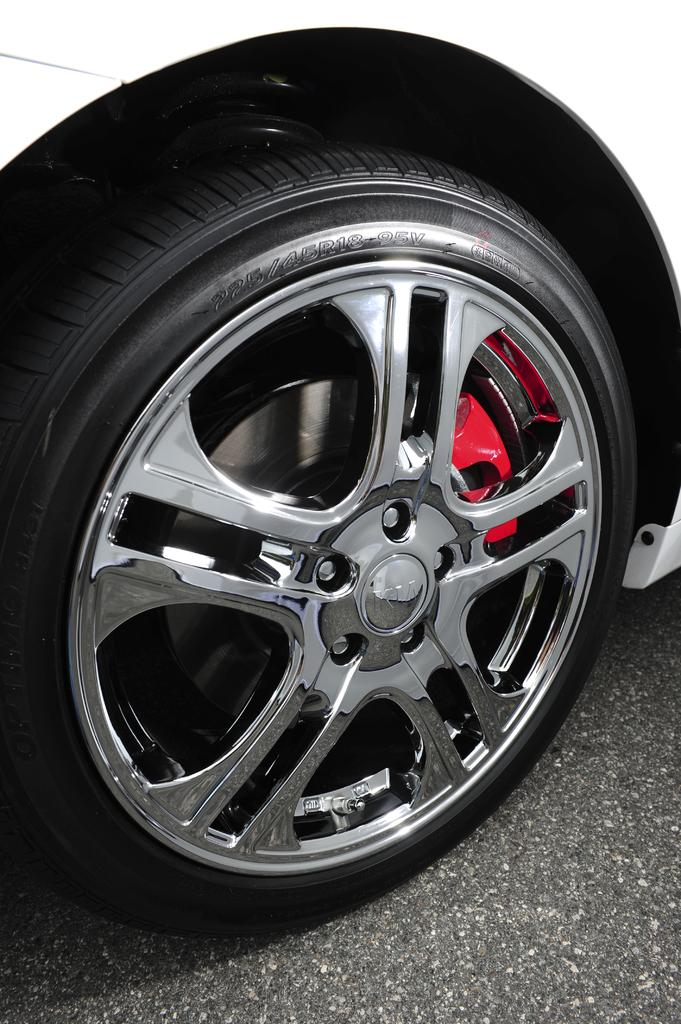What object related to a vehicle can be seen in the image? There is a tire of a vehicle in the image. What type of surface is visible in the image? There is a road visible in the image. How does the tire take a breath in the image? Tires do not breathe, as they are inanimate objects. 